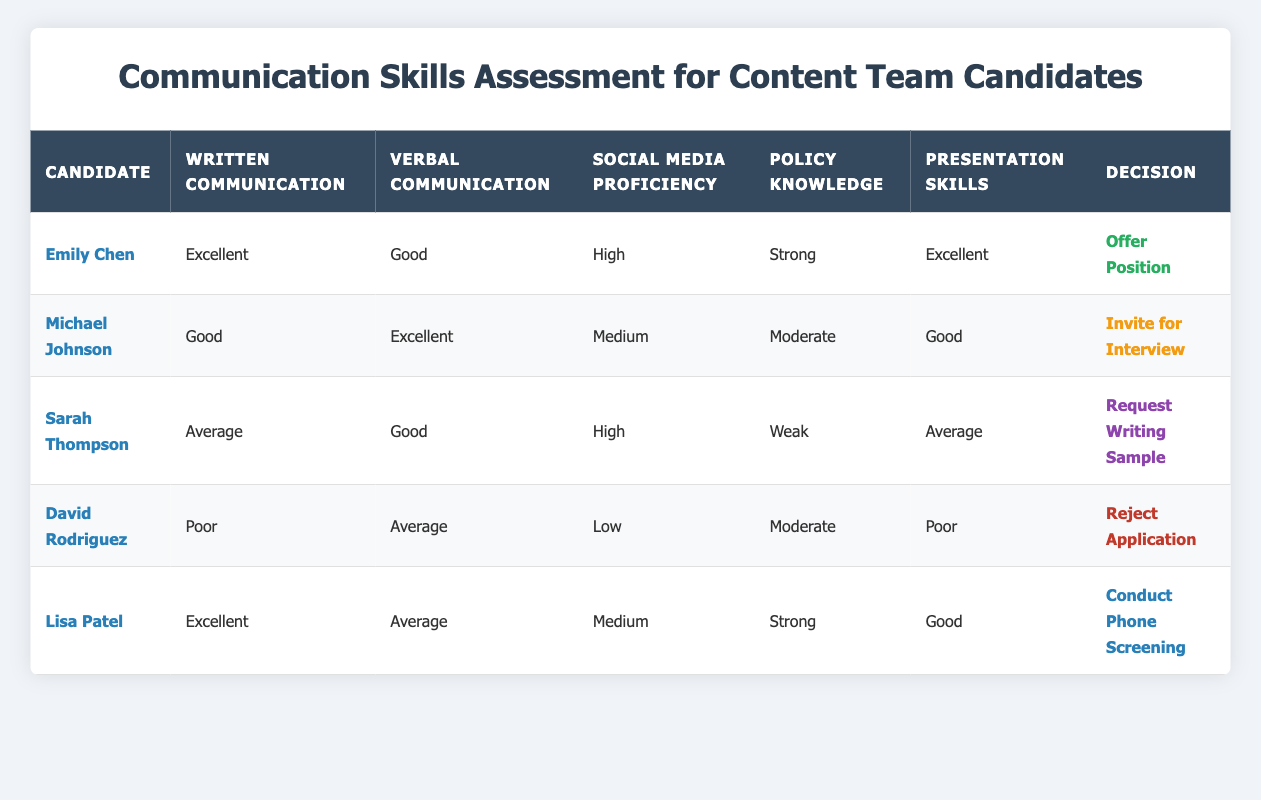What is the decision for Emily Chen? Emily Chen has excellent written communication skills, good verbal communication skills, high social media proficiency, strong policy knowledge, and excellent presentation skills. According to the decision rule, such a combination leads to the decision to offer her the position.
Answer: Offer Position How many candidates received an invitation for an interview? There is one candidate, Michael Johnson, who received an invitation for an interview, as his skills meet the criteria for this decision.
Answer: 1 Is Lisa Patel's social media proficiency considered high? Lisa Patel's social media proficiency is rated as medium, not high according to the table.
Answer: No Which candidates could potentially receive an offer? To receive an offer, candidates must have excellent skills in written communication and presentation, and either good or excellent skills in verbal communication. In the table, only Emily Chen meets all these criteria.
Answer: Emily Chen What is the average presentation skill rating of the candidates? The presentation skills ratings are excellent, good, average, poor, good. To find the average: convert ratings to numerical values (excellent=4, good=3, average=2, poor=1), calculate total (4 + 3 + 2 + 1 + 3 = 13), and divide by the number of candidates (5). The average is 13/5 = 2.6, which corresponds to a rating of average.
Answer: Average How many candidates have strong policy knowledge? The table indicates that both Emily Chen and Lisa Patel have strong policy knowledge, totaling two candidates.
Answer: 2 Did any candidate receive a decision to reject their application? Yes, David Rodriguez has a decision of reject application based on his poor performance in several communication skill areas.
Answer: Yes What is the decision for Sarah Thompson? Sarah Thompson has average written communication, good verbal communication, high social media proficiency, weak policy knowledge, and average presentation. Based on these criteria, she is requested to provide a writing sample.
Answer: Request Writing Sample 